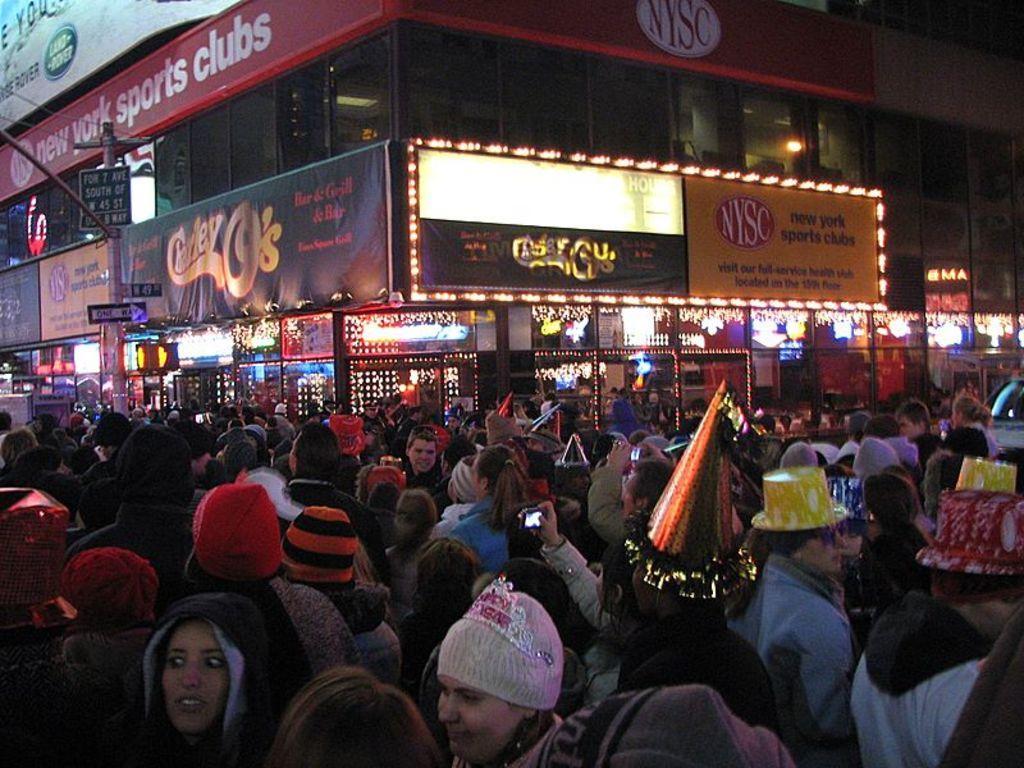In one or two sentences, can you explain what this image depicts? In this image we can see a group of people standing on the road. In that we can see some people wearing hats. on the backside we can see a building with lighting and boards. 